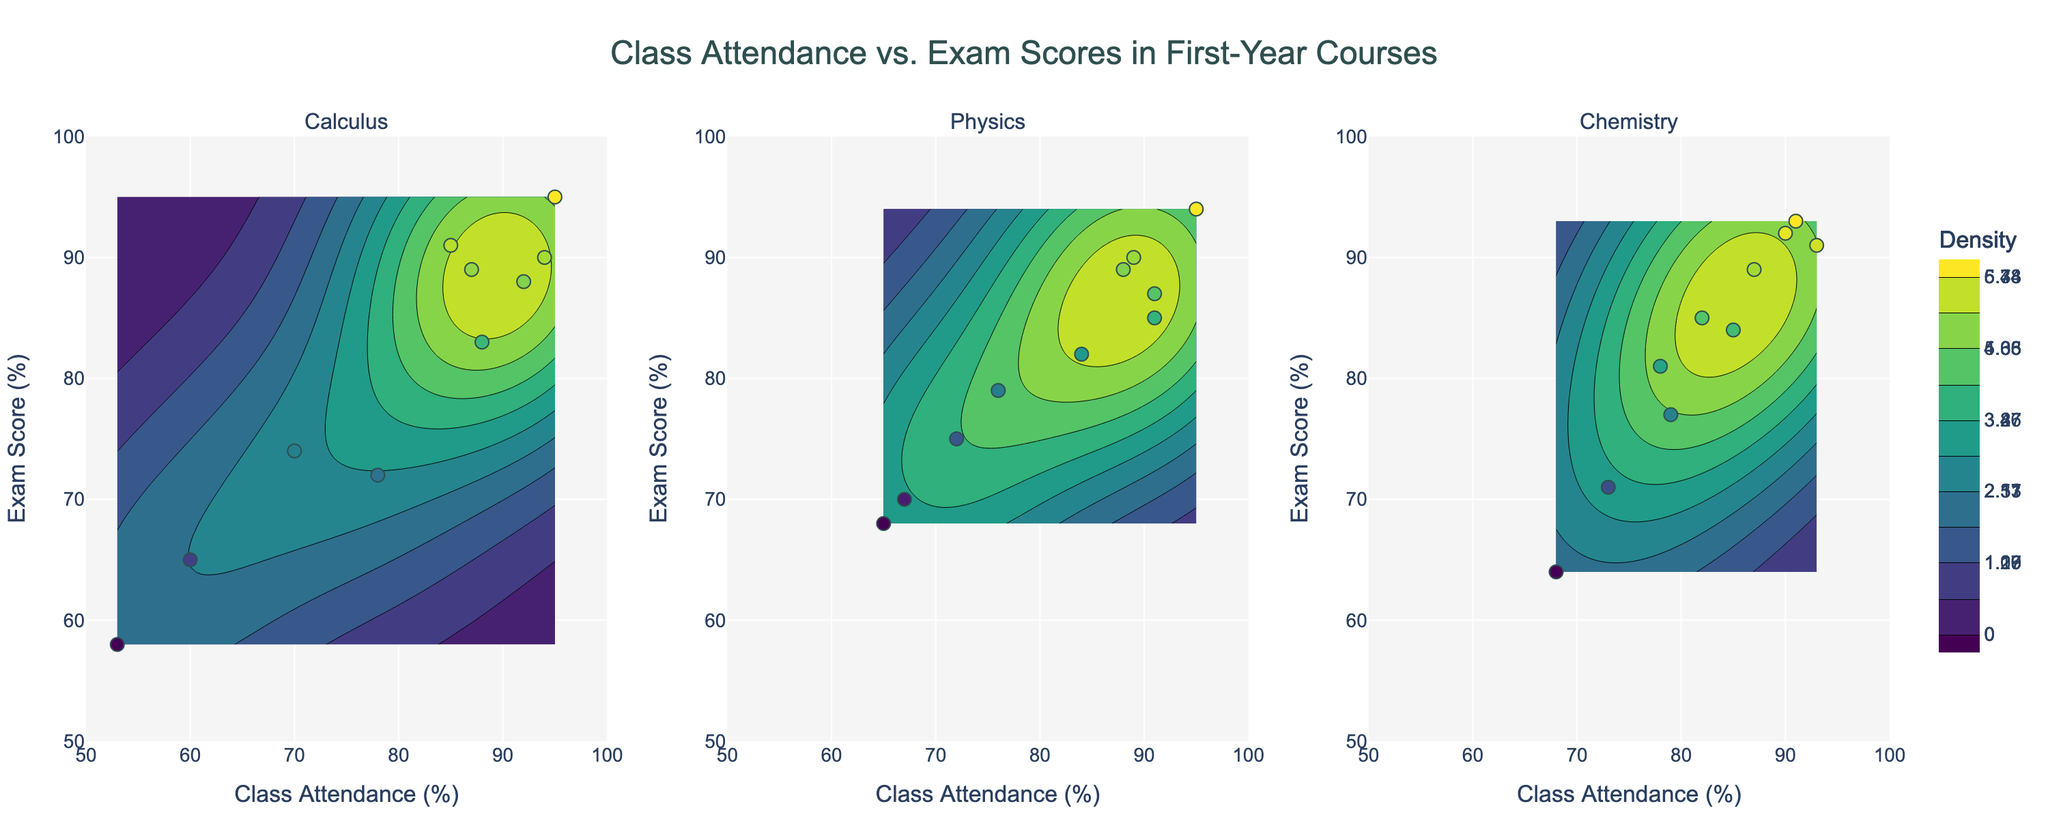what is the range of class attendance percentages shown on the figure? By looking at the x-axes, we can see the range of class attendance percentages. The figure's x-axes are labeled "Class Attendance (%)", and the tick marks indicate the range from 50 to 100 percent.
Answer: 50-100 How many data points are there for each course? Each subplot corresponds to a course: Calculus, Physics, and Chemistry. By counting the dots in each subplot, we can determine the number of data points for each course. Calculus has 10 data points (students), Physics also has 10, and Chemistry has 10.
Answer: 10 each Which course has the highest density of high exam scores and high class attendance? We observe the contour density and scatter markers within each subplot. The highest density areas are shown by the darkest contours. For "Calculus," there's significant density at higher values, seen on the right-hand side. "Physics" and "Chemistry" also show high densities but less concentrated. Thus, Calculus has the highest concentration of high scores and attendance.
Answer: Calculus What is the title of the figure? The title is prominently displayed at the top of the figure. It reads: "Class Attendance vs. Exam Scores in First-Year Courses."
Answer: Class Attendance vs. Exam Scores in First-Year Courses What is the overall trend observed between class attendance and exam scores across all courses? By observing the scatter plots and the contours in each subplot, there is a discernible trend: higher class attendance generally correlates with higher exam scores. This trend is indicated by the clustering of high attendance and high exam score points towards the top-right in each subplot.
Answer: Higher attendance, higher scores Which course has the student with the lowest exam score? Each subplot shows individual student scores. By locating the lowest point on the y-axis in each subplot, we see that the lowest exam score is in the "Calculus" subplot where one student scored just above 58%.
Answer: Calculus How does the variability in exam scores compare between courses? We compare the spread of the exam scores along the y-axis for each subplot. "Calculus" shows a wide range of scores from about 58% to 95%. "Physics" ranges from about 68% to 91%. "Chemistry" scores range from 64% to 93%. Thus, Calculus has the highest variability.
Answer: Calculus has the highest variability Which course has the highest density of mid-range exam scores (70-80%)? By examining the density contours in each subplot, we focus on the mid-range of exam scores (70-80%). For "Calculus," the density in this range is low. "Physics" has some density in this range, but "Chemistry" shows noticeable density in the 70-80% range, as indicated by the contour intensities.
Answer: Chemistry Which course shows the lowest attendance percentage? Identify the lowest x-axis value in each subplot. The lowest class attendance percentage is seen in the "Calculus" subplot, around 53%.
Answer: Calculus 